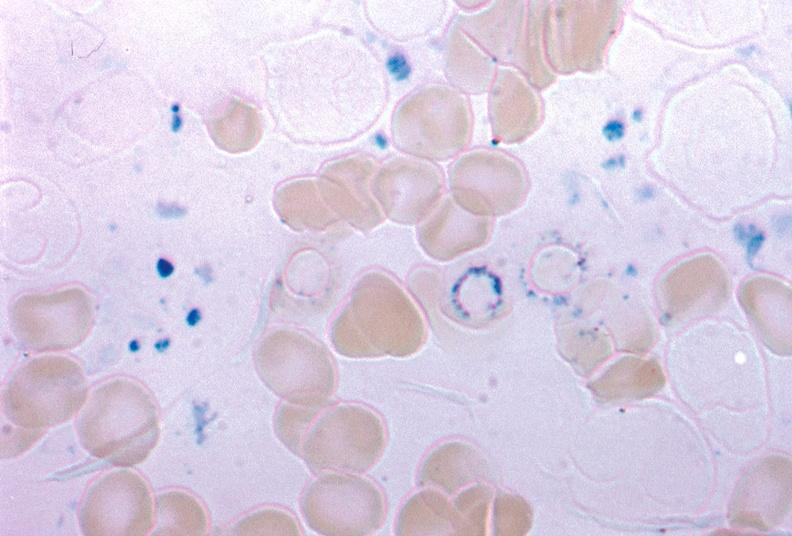what is present?
Answer the question using a single word or phrase. Bone marrow 